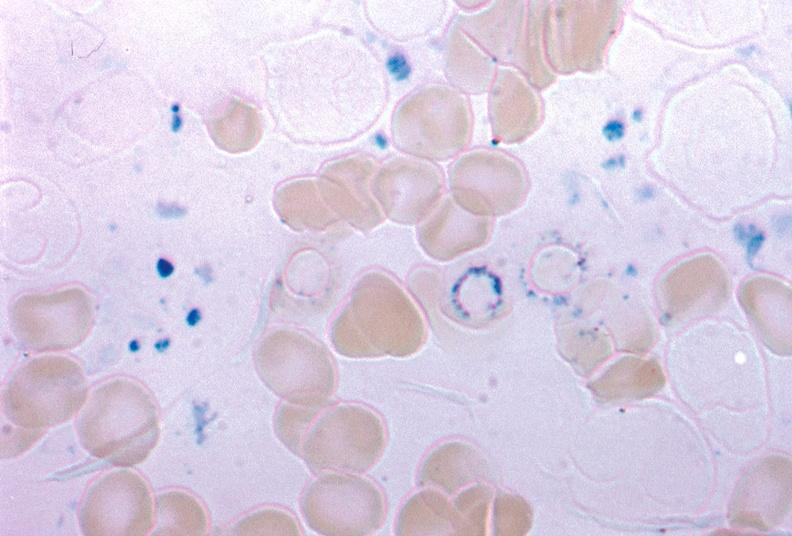what is present?
Answer the question using a single word or phrase. Bone marrow 